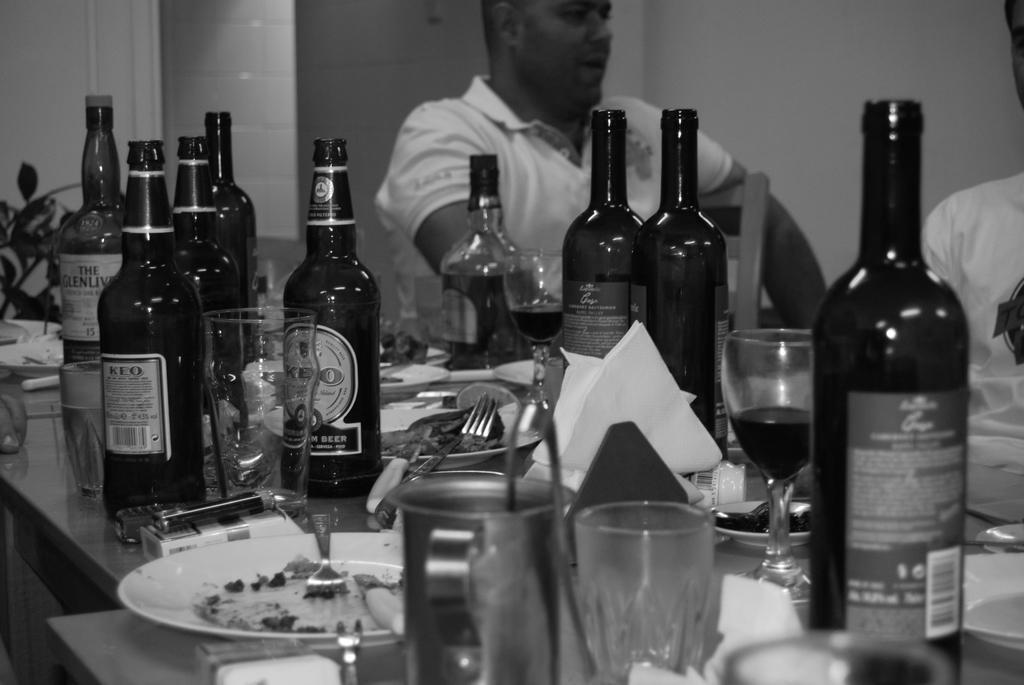Please provide a concise description of this image. There is man white t-shirt sitting. In front of him there is a table. On that table there are many bottles, glasses,plates, fork, some packet, mobile. 